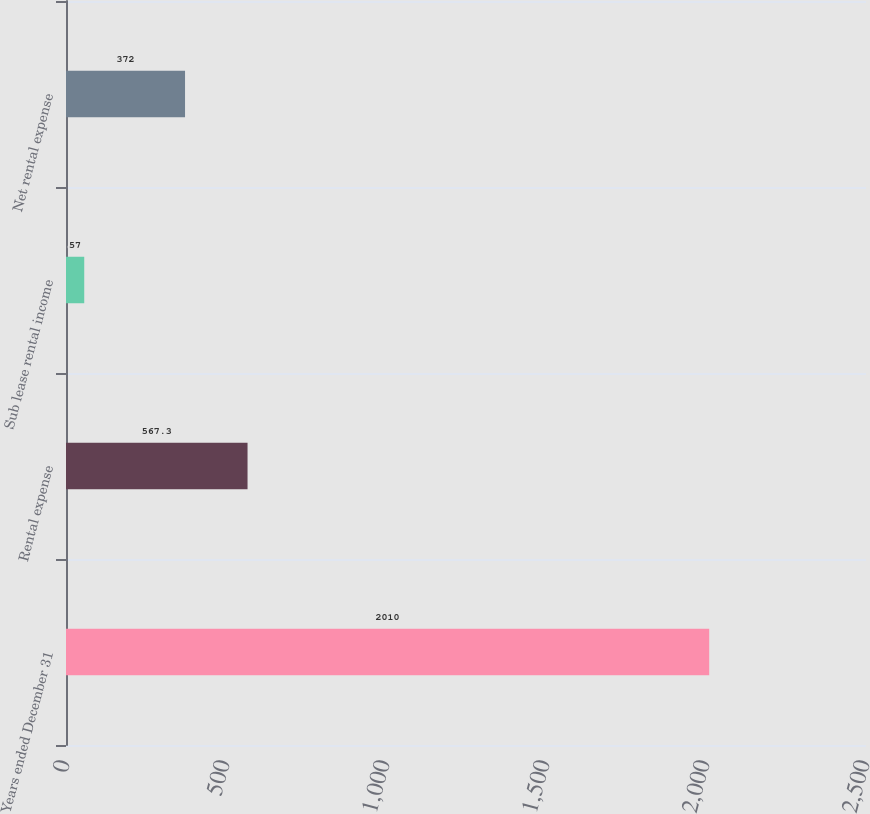Convert chart to OTSL. <chart><loc_0><loc_0><loc_500><loc_500><bar_chart><fcel>Years ended December 31<fcel>Rental expense<fcel>Sub lease rental income<fcel>Net rental expense<nl><fcel>2010<fcel>567.3<fcel>57<fcel>372<nl></chart> 